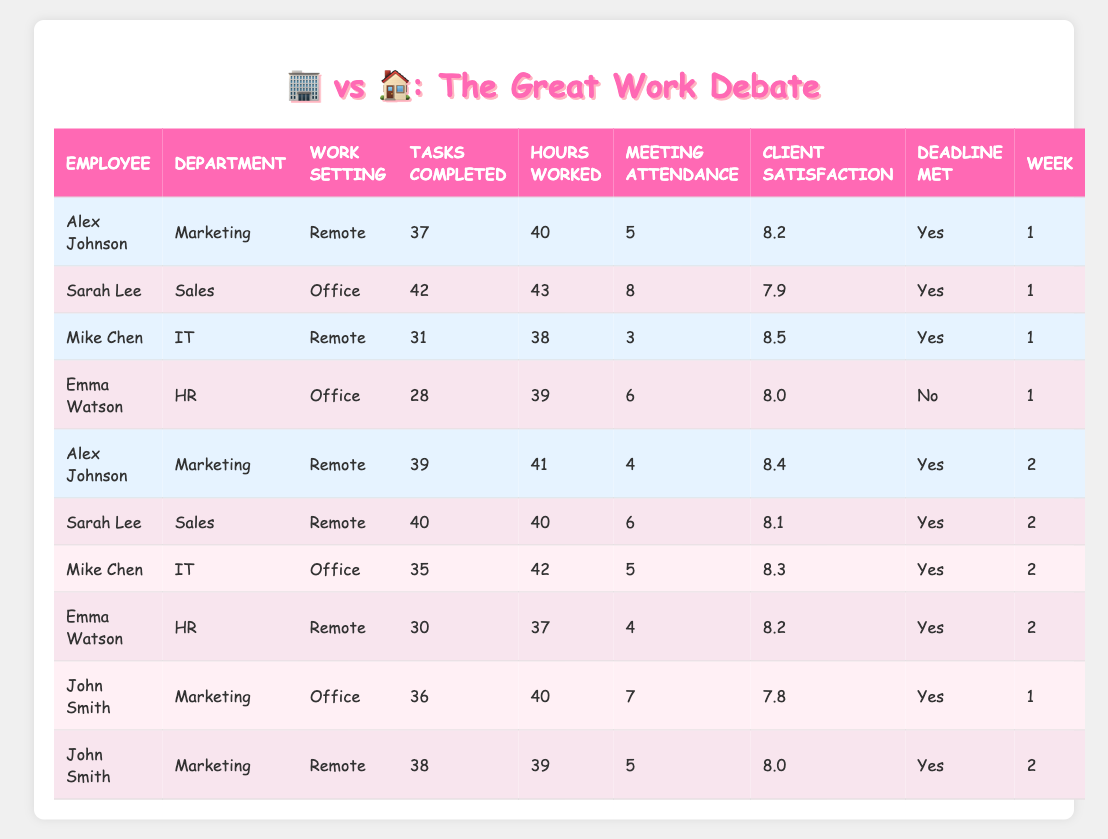What was the highest number of tasks completed in a single week? Looking through the table, I see that Sarah Lee in the Office setting completed 42 tasks in week 1, which is the highest single value observed.
Answer: 42 How many hours did Mike Chen work in the Office setting? In the table, Mike Chen's entry under the Office setting shows that he worked a total of 42 hours in week 2.
Answer: 42 Did Emma Watson meet her deadlines in both weeks? In week 1, Emma Watson did not meet her deadline (marked as No), but in week 2, she did meet her deadline (marked as Yes). Therefore, the answer is No.
Answer: No What is the average client satisfaction rating for employees working remotely? For employees working remotely, their client satisfaction ratings are 8.2, 8.5, 8.4, 8.1, and 8.2. Summing them gives 41.4, and with 5 entries, the average is calculated as 41.4/5 = 8.28.
Answer: 8.28 Which employee had the lowest tasks completed in the Remote setting? Looking at the Remote entries, Mike Chen completed 31 tasks while all other entries (Alex Johnson and Emma Watson) completed higher numbers: 37, 39, 40, and 30. Therefore, Mike Chen had the lowest.
Answer: Mike Chen What was the total number of tasks completed by John Smith across all weeks? John Smith completed 36 tasks in Office for week 1 and 38 tasks in Remote for week 2, totaling 36 + 38 = 74 tasks across both weeks.
Answer: 74 Which department had the most employees working remotely? In the table, both the Marketing department (Alex Johnson and John Smith) and HR department (Emma Watson) had two entries for remote work. Therefore, both departments are tied for the most employees in remote work settings.
Answer: Marketing and HR Did Sarah Lee have higher client satisfaction when working in the Remote setting compared to the Office? Sarah Lee's client satisfaction score in the Office setting is 7.9, while in the Remote setting it is 8.1. Since 8.1 is greater than 7.9, she indeed had higher satisfaction when working remotely.
Answer: Yes What was the overall rate of deadlines met by remote workers? Analyzing deadlines met in remote work settings: Alex Johnson (Yes), Mike Chen (Yes), Sarah Lee (Yes), Emma Watson (Yes) total 4 met deadlines out of 5 employees. Therefore, the percentage is 4 out of 5, or 80% of deadlines met.
Answer: 80% 